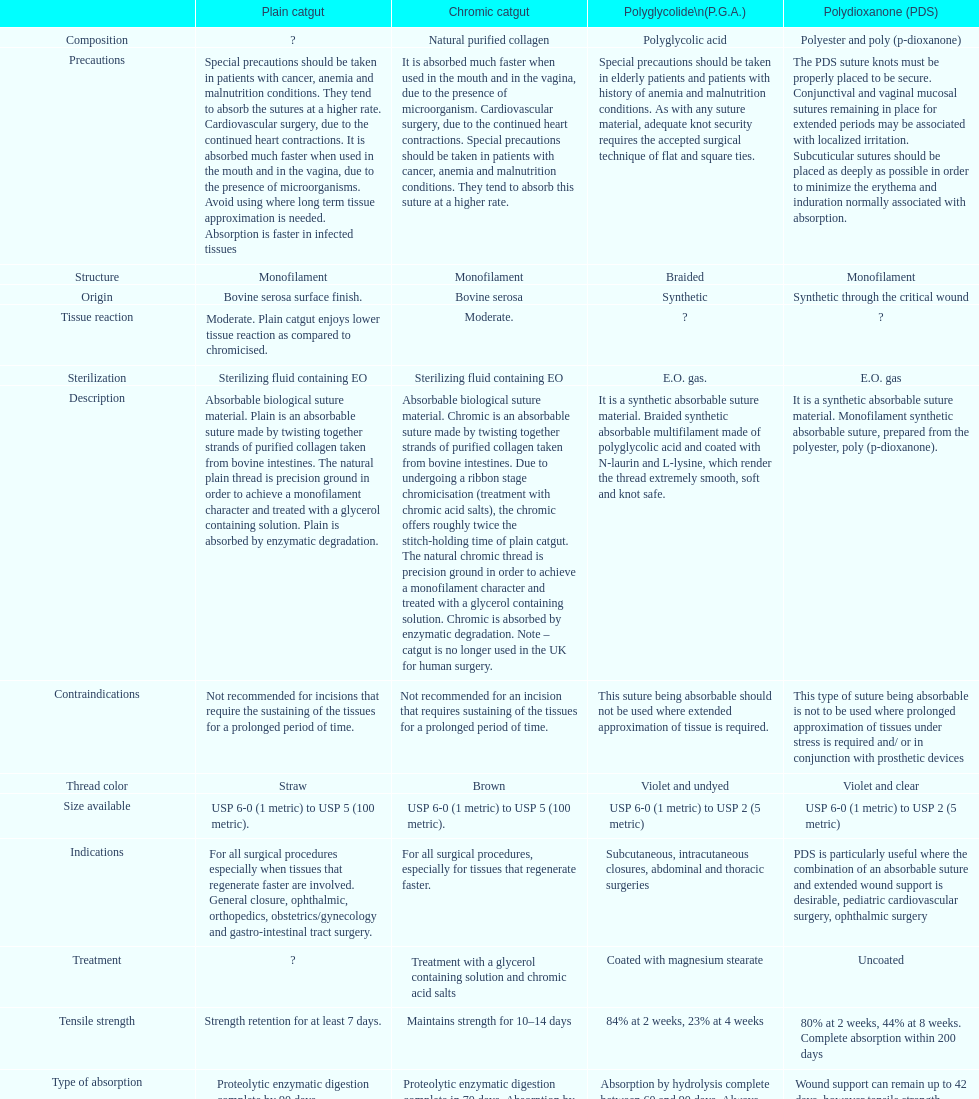What type of sutures are no longer used in the u.k. for human surgery? Chromic catgut. 